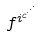Convert formula to latex. <formula><loc_0><loc_0><loc_500><loc_500>f ^ { i ^ { c ^ { \cdot ^ { \cdot ^ { \cdot } } } } }</formula> 